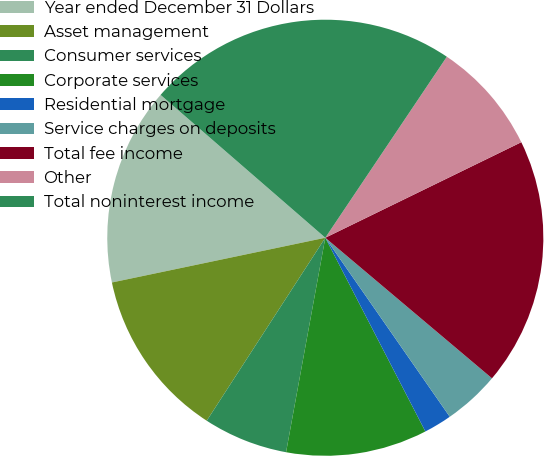Convert chart to OTSL. <chart><loc_0><loc_0><loc_500><loc_500><pie_chart><fcel>Year ended December 31 Dollars<fcel>Asset management<fcel>Consumer services<fcel>Corporate services<fcel>Residential mortgage<fcel>Service charges on deposits<fcel>Total fee income<fcel>Other<fcel>Total noninterest income<nl><fcel>14.66%<fcel>12.56%<fcel>6.27%<fcel>10.47%<fcel>2.08%<fcel>4.18%<fcel>18.37%<fcel>8.37%<fcel>23.04%<nl></chart> 